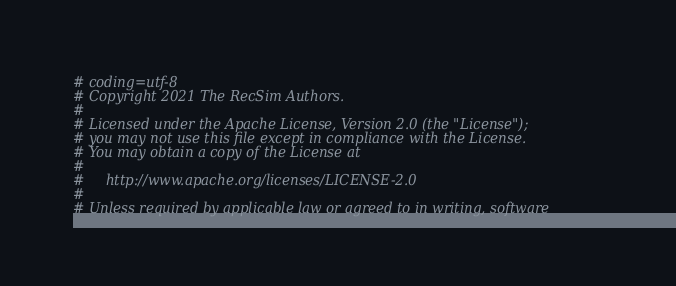Convert code to text. <code><loc_0><loc_0><loc_500><loc_500><_Python_># coding=utf-8
# Copyright 2021 The RecSim Authors.
#
# Licensed under the Apache License, Version 2.0 (the "License");
# you may not use this file except in compliance with the License.
# You may obtain a copy of the License at
#
#     http://www.apache.org/licenses/LICENSE-2.0
#
# Unless required by applicable law or agreed to in writing, software</code> 